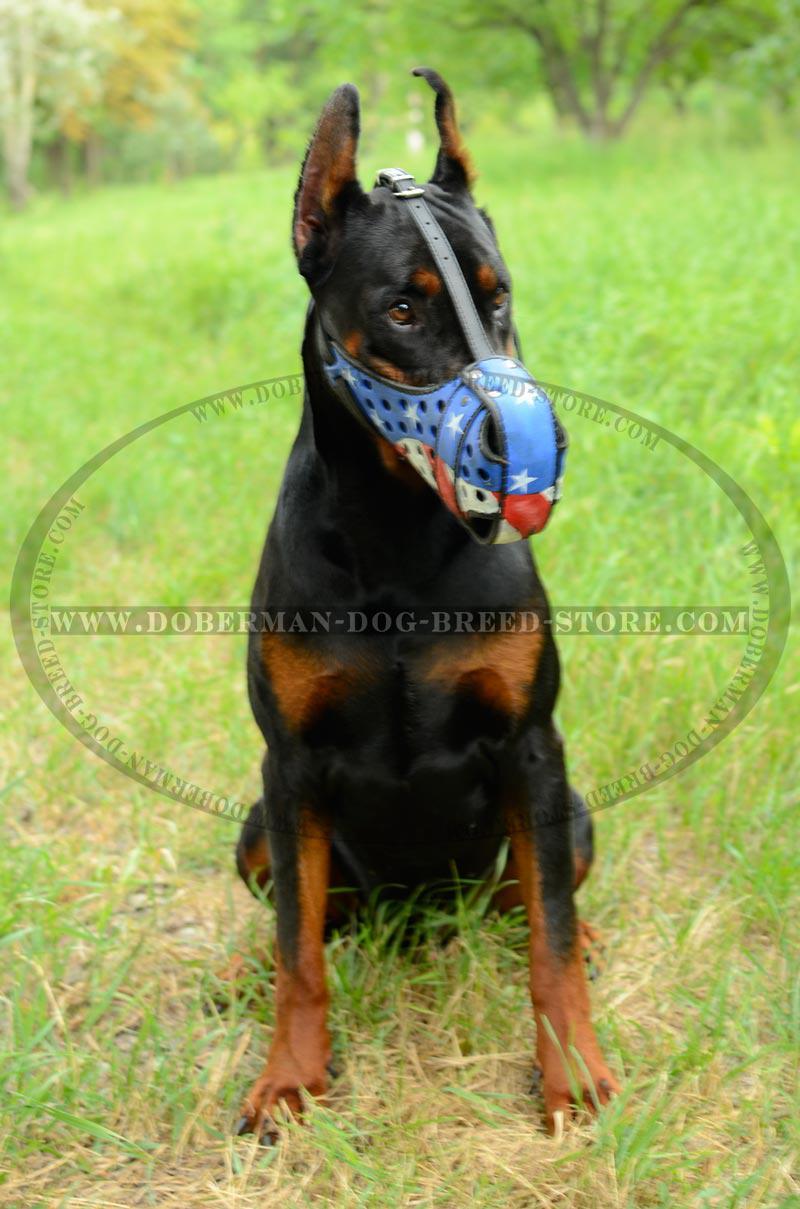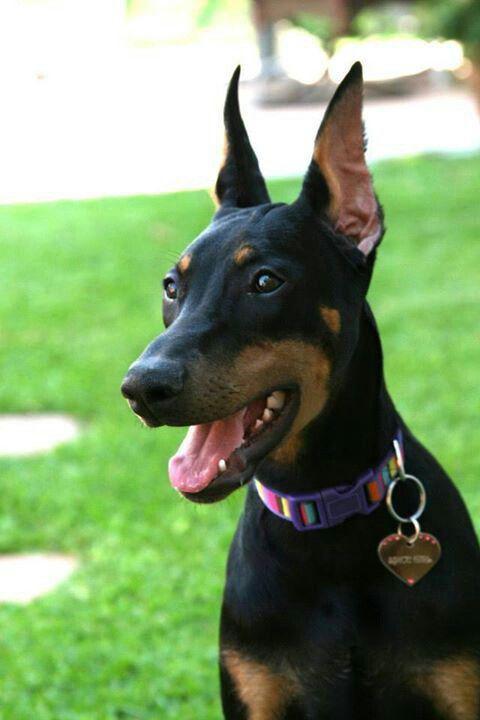The first image is the image on the left, the second image is the image on the right. Considering the images on both sides, is "One dog is sitting and isn't wearing a dog collar." valid? Answer yes or no. Yes. The first image is the image on the left, the second image is the image on the right. Given the left and right images, does the statement "At least one image features an adult doberman with erect pointy ears in an upright sitting position." hold true? Answer yes or no. Yes. 